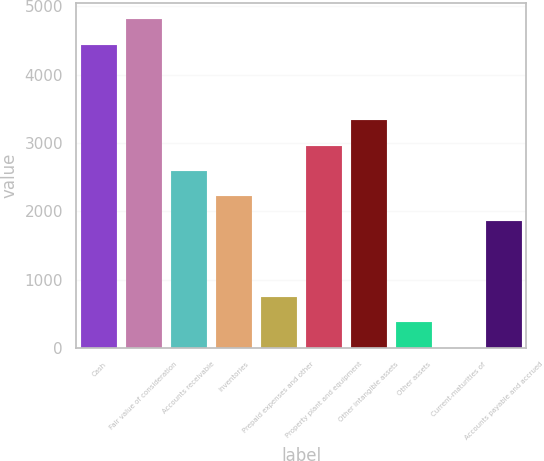Convert chart to OTSL. <chart><loc_0><loc_0><loc_500><loc_500><bar_chart><fcel>Cash<fcel>Fair value of consideration<fcel>Accounts receivable<fcel>Inventories<fcel>Prepaid expenses and other<fcel>Property plant and equipment<fcel>Other intangible assets<fcel>Other assets<fcel>Current-maturities of<fcel>Accounts payable and accrued<nl><fcel>4439.6<fcel>4809.4<fcel>2590.6<fcel>2220.8<fcel>741.6<fcel>2960.4<fcel>3330.2<fcel>371.8<fcel>2<fcel>1851<nl></chart> 